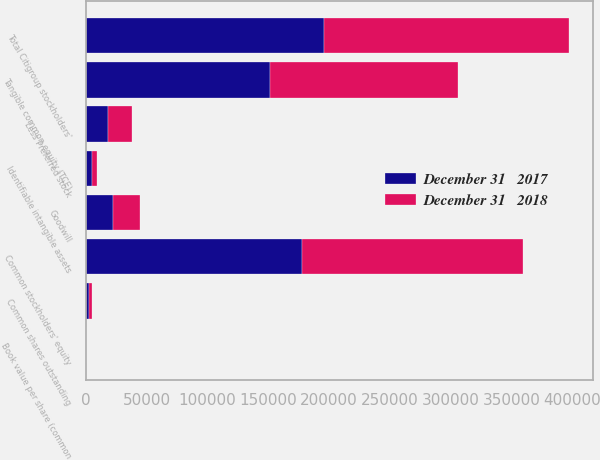Convert chart. <chart><loc_0><loc_0><loc_500><loc_500><stacked_bar_chart><ecel><fcel>Total Citigroup stockholders'<fcel>Less Preferred stock<fcel>Common stockholders' equity<fcel>Goodwill<fcel>Identifiable intangible assets<fcel>Tangible common equity (TCE)<fcel>Common shares outstanding<fcel>Book value per share (common<nl><fcel>December 31   2017<fcel>196220<fcel>18460<fcel>177760<fcel>22046<fcel>4636<fcel>151078<fcel>2368.5<fcel>75.05<nl><fcel>December 31   2018<fcel>200740<fcel>19253<fcel>181487<fcel>22256<fcel>4588<fcel>154611<fcel>2569.9<fcel>70.62<nl></chart> 